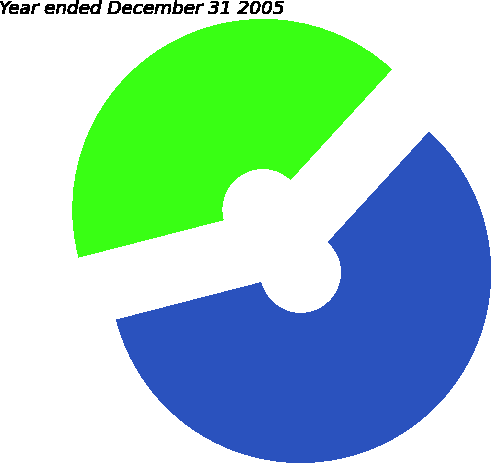Convert chart to OTSL. <chart><loc_0><loc_0><loc_500><loc_500><pie_chart><fcel>Year ended December 31 2006<fcel>Year ended December 31 2005<nl><fcel>59.17%<fcel>40.83%<nl></chart> 